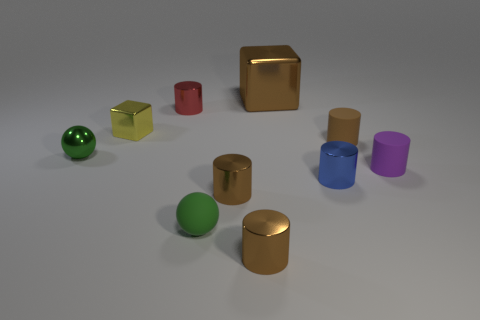Subtract all brown balls. How many brown cylinders are left? 3 Subtract all red metal cylinders. How many cylinders are left? 5 Subtract all red cylinders. How many cylinders are left? 5 Subtract all red cylinders. Subtract all blue blocks. How many cylinders are left? 5 Subtract all balls. How many objects are left? 8 Subtract 0 blue balls. How many objects are left? 10 Subtract all small purple things. Subtract all small red cylinders. How many objects are left? 8 Add 4 spheres. How many spheres are left? 6 Add 1 small cyan spheres. How many small cyan spheres exist? 1 